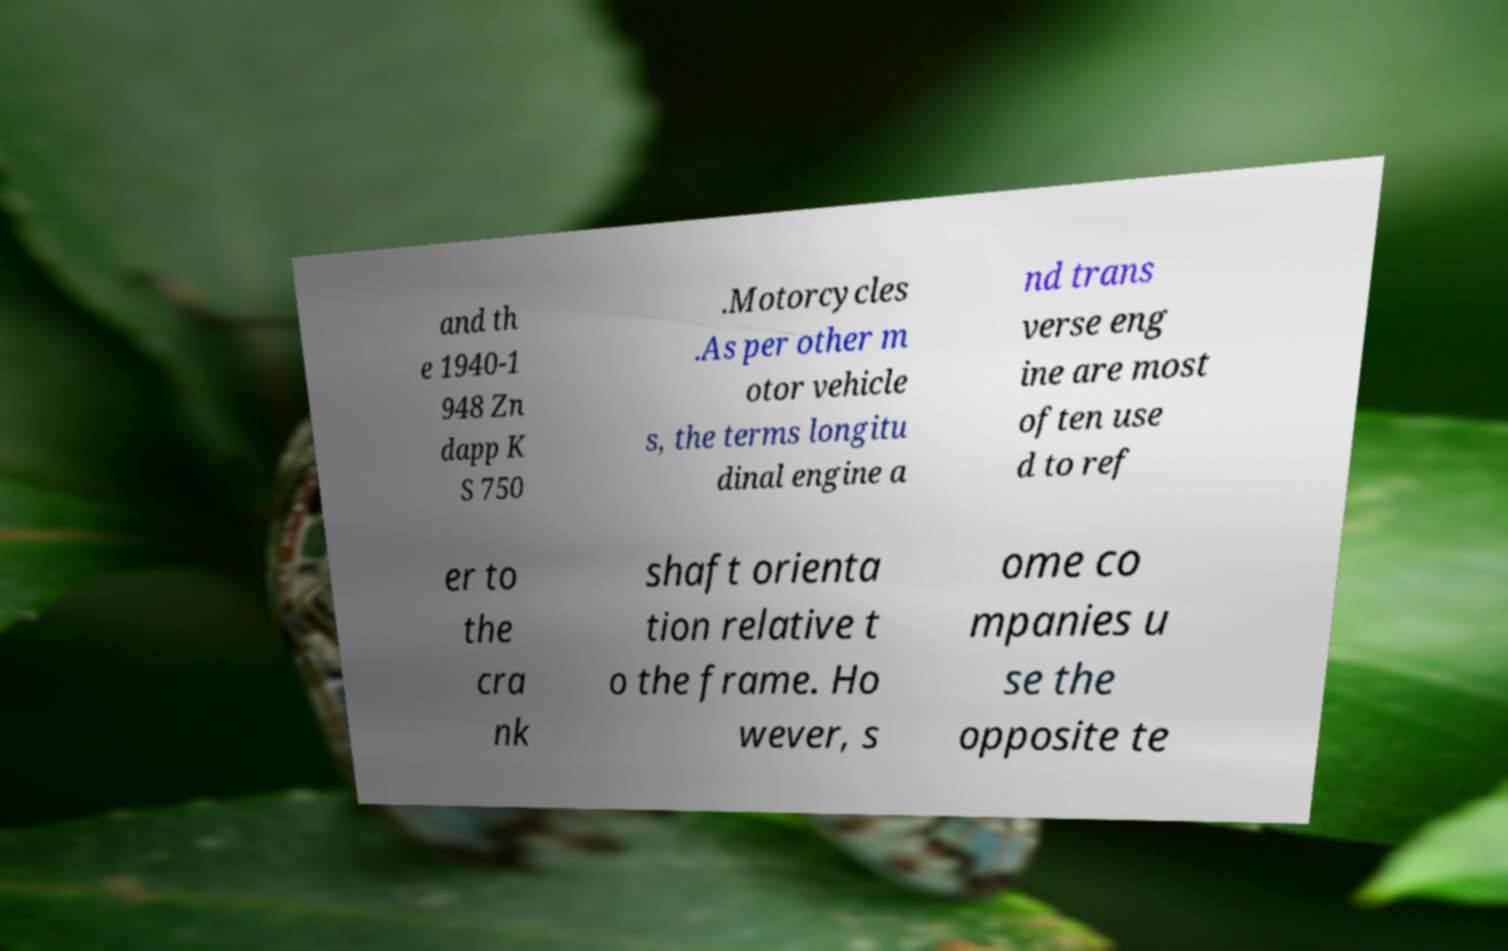Could you assist in decoding the text presented in this image and type it out clearly? and th e 1940-1 948 Zn dapp K S 750 .Motorcycles .As per other m otor vehicle s, the terms longitu dinal engine a nd trans verse eng ine are most often use d to ref er to the cra nk shaft orienta tion relative t o the frame. Ho wever, s ome co mpanies u se the opposite te 